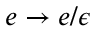Convert formula to latex. <formula><loc_0><loc_0><loc_500><loc_500>e \rightarrow e / \epsilon</formula> 